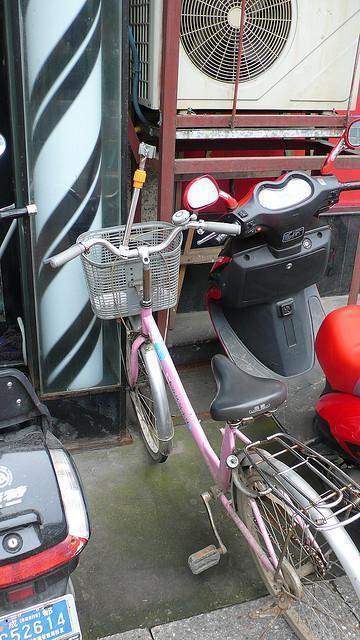What color is the frame of the girl's bike painted out to be?
Answer the question by selecting the correct answer among the 4 following choices and explain your choice with a short sentence. The answer should be formatted with the following format: `Answer: choice
Rationale: rationale.`
Options: Blue, pink, purple, yellow. Answer: pink.
Rationale: The color is pink. 